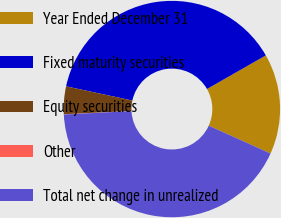<chart> <loc_0><loc_0><loc_500><loc_500><pie_chart><fcel>Year Ended December 31<fcel>Fixed maturity securities<fcel>Equity securities<fcel>Other<fcel>Total net change in unrealized<nl><fcel>15.0%<fcel>38.37%<fcel>4.13%<fcel>0.04%<fcel>42.46%<nl></chart> 